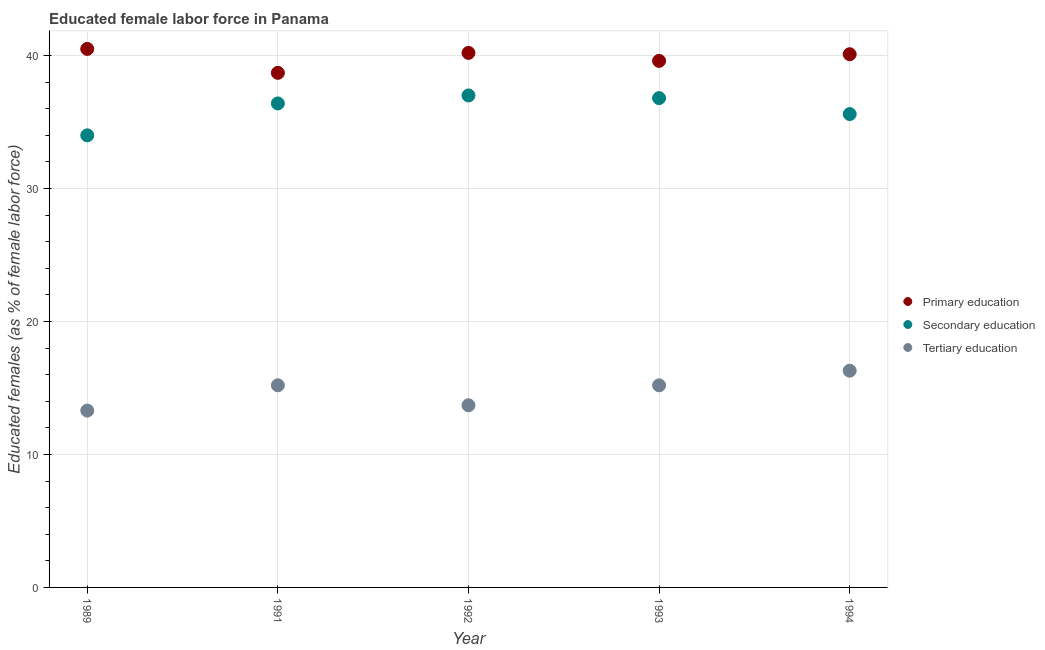How many different coloured dotlines are there?
Ensure brevity in your answer.  3. Is the number of dotlines equal to the number of legend labels?
Offer a very short reply. Yes. What is the percentage of female labor force who received primary education in 1991?
Keep it short and to the point. 38.7. Across all years, what is the maximum percentage of female labor force who received tertiary education?
Your answer should be compact. 16.3. Across all years, what is the minimum percentage of female labor force who received tertiary education?
Keep it short and to the point. 13.3. In which year was the percentage of female labor force who received secondary education maximum?
Provide a succinct answer. 1992. In which year was the percentage of female labor force who received secondary education minimum?
Give a very brief answer. 1989. What is the total percentage of female labor force who received secondary education in the graph?
Keep it short and to the point. 179.8. What is the difference between the percentage of female labor force who received secondary education in 1989 and that in 1991?
Ensure brevity in your answer.  -2.4. What is the difference between the percentage of female labor force who received primary education in 1991 and the percentage of female labor force who received secondary education in 1992?
Give a very brief answer. 1.7. What is the average percentage of female labor force who received secondary education per year?
Your response must be concise. 35.96. In the year 1993, what is the difference between the percentage of female labor force who received tertiary education and percentage of female labor force who received secondary education?
Provide a succinct answer. -21.6. In how many years, is the percentage of female labor force who received primary education greater than 10 %?
Ensure brevity in your answer.  5. What is the ratio of the percentage of female labor force who received secondary education in 1991 to that in 1993?
Provide a succinct answer. 0.99. Is the percentage of female labor force who received secondary education in 1991 less than that in 1993?
Offer a terse response. Yes. Is the difference between the percentage of female labor force who received tertiary education in 1991 and 1994 greater than the difference between the percentage of female labor force who received secondary education in 1991 and 1994?
Ensure brevity in your answer.  No. What is the difference between the highest and the second highest percentage of female labor force who received tertiary education?
Keep it short and to the point. 1.1. What is the difference between the highest and the lowest percentage of female labor force who received primary education?
Offer a terse response. 1.8. In how many years, is the percentage of female labor force who received secondary education greater than the average percentage of female labor force who received secondary education taken over all years?
Make the answer very short. 3. Is it the case that in every year, the sum of the percentage of female labor force who received primary education and percentage of female labor force who received secondary education is greater than the percentage of female labor force who received tertiary education?
Your answer should be compact. Yes. Is the percentage of female labor force who received primary education strictly greater than the percentage of female labor force who received tertiary education over the years?
Your answer should be compact. Yes. Is the percentage of female labor force who received tertiary education strictly less than the percentage of female labor force who received primary education over the years?
Your answer should be compact. Yes. How many dotlines are there?
Your answer should be very brief. 3. How many years are there in the graph?
Your answer should be compact. 5. Are the values on the major ticks of Y-axis written in scientific E-notation?
Your answer should be compact. No. What is the title of the graph?
Your response must be concise. Educated female labor force in Panama. What is the label or title of the X-axis?
Give a very brief answer. Year. What is the label or title of the Y-axis?
Provide a succinct answer. Educated females (as % of female labor force). What is the Educated females (as % of female labor force) of Primary education in 1989?
Your answer should be very brief. 40.5. What is the Educated females (as % of female labor force) in Secondary education in 1989?
Provide a short and direct response. 34. What is the Educated females (as % of female labor force) of Tertiary education in 1989?
Provide a succinct answer. 13.3. What is the Educated females (as % of female labor force) in Primary education in 1991?
Your answer should be compact. 38.7. What is the Educated females (as % of female labor force) in Secondary education in 1991?
Make the answer very short. 36.4. What is the Educated females (as % of female labor force) of Tertiary education in 1991?
Offer a terse response. 15.2. What is the Educated females (as % of female labor force) of Primary education in 1992?
Provide a short and direct response. 40.2. What is the Educated females (as % of female labor force) in Tertiary education in 1992?
Your answer should be very brief. 13.7. What is the Educated females (as % of female labor force) of Primary education in 1993?
Your response must be concise. 39.6. What is the Educated females (as % of female labor force) of Secondary education in 1993?
Provide a succinct answer. 36.8. What is the Educated females (as % of female labor force) in Tertiary education in 1993?
Make the answer very short. 15.2. What is the Educated females (as % of female labor force) of Primary education in 1994?
Offer a terse response. 40.1. What is the Educated females (as % of female labor force) of Secondary education in 1994?
Provide a short and direct response. 35.6. What is the Educated females (as % of female labor force) in Tertiary education in 1994?
Your answer should be very brief. 16.3. Across all years, what is the maximum Educated females (as % of female labor force) of Primary education?
Your response must be concise. 40.5. Across all years, what is the maximum Educated females (as % of female labor force) in Tertiary education?
Provide a short and direct response. 16.3. Across all years, what is the minimum Educated females (as % of female labor force) of Primary education?
Provide a succinct answer. 38.7. Across all years, what is the minimum Educated females (as % of female labor force) of Tertiary education?
Provide a succinct answer. 13.3. What is the total Educated females (as % of female labor force) in Primary education in the graph?
Give a very brief answer. 199.1. What is the total Educated females (as % of female labor force) in Secondary education in the graph?
Your answer should be very brief. 179.8. What is the total Educated females (as % of female labor force) of Tertiary education in the graph?
Offer a very short reply. 73.7. What is the difference between the Educated females (as % of female labor force) in Secondary education in 1989 and that in 1991?
Provide a short and direct response. -2.4. What is the difference between the Educated females (as % of female labor force) of Secondary education in 1989 and that in 1993?
Ensure brevity in your answer.  -2.8. What is the difference between the Educated females (as % of female labor force) of Tertiary education in 1989 and that in 1993?
Keep it short and to the point. -1.9. What is the difference between the Educated females (as % of female labor force) in Primary education in 1989 and that in 1994?
Offer a very short reply. 0.4. What is the difference between the Educated females (as % of female labor force) of Secondary education in 1989 and that in 1994?
Your answer should be compact. -1.6. What is the difference between the Educated females (as % of female labor force) of Tertiary education in 1989 and that in 1994?
Your response must be concise. -3. What is the difference between the Educated females (as % of female labor force) of Primary education in 1991 and that in 1992?
Provide a short and direct response. -1.5. What is the difference between the Educated females (as % of female labor force) of Secondary education in 1991 and that in 1992?
Provide a succinct answer. -0.6. What is the difference between the Educated females (as % of female labor force) in Primary education in 1991 and that in 1993?
Give a very brief answer. -0.9. What is the difference between the Educated females (as % of female labor force) in Secondary education in 1991 and that in 1993?
Make the answer very short. -0.4. What is the difference between the Educated females (as % of female labor force) of Tertiary education in 1991 and that in 1993?
Your answer should be compact. 0. What is the difference between the Educated females (as % of female labor force) of Primary education in 1991 and that in 1994?
Your answer should be compact. -1.4. What is the difference between the Educated females (as % of female labor force) in Tertiary education in 1991 and that in 1994?
Provide a short and direct response. -1.1. What is the difference between the Educated females (as % of female labor force) in Primary education in 1992 and that in 1993?
Give a very brief answer. 0.6. What is the difference between the Educated females (as % of female labor force) of Secondary education in 1992 and that in 1993?
Keep it short and to the point. 0.2. What is the difference between the Educated females (as % of female labor force) in Tertiary education in 1992 and that in 1993?
Offer a very short reply. -1.5. What is the difference between the Educated females (as % of female labor force) of Primary education in 1992 and that in 1994?
Give a very brief answer. 0.1. What is the difference between the Educated females (as % of female labor force) of Secondary education in 1992 and that in 1994?
Provide a short and direct response. 1.4. What is the difference between the Educated females (as % of female labor force) in Tertiary education in 1992 and that in 1994?
Provide a succinct answer. -2.6. What is the difference between the Educated females (as % of female labor force) of Primary education in 1993 and that in 1994?
Ensure brevity in your answer.  -0.5. What is the difference between the Educated females (as % of female labor force) in Primary education in 1989 and the Educated females (as % of female labor force) in Tertiary education in 1991?
Make the answer very short. 25.3. What is the difference between the Educated females (as % of female labor force) of Primary education in 1989 and the Educated females (as % of female labor force) of Secondary education in 1992?
Provide a succinct answer. 3.5. What is the difference between the Educated females (as % of female labor force) of Primary education in 1989 and the Educated females (as % of female labor force) of Tertiary education in 1992?
Provide a succinct answer. 26.8. What is the difference between the Educated females (as % of female labor force) in Secondary education in 1989 and the Educated females (as % of female labor force) in Tertiary education in 1992?
Your response must be concise. 20.3. What is the difference between the Educated females (as % of female labor force) in Primary education in 1989 and the Educated females (as % of female labor force) in Tertiary education in 1993?
Ensure brevity in your answer.  25.3. What is the difference between the Educated females (as % of female labor force) in Secondary education in 1989 and the Educated females (as % of female labor force) in Tertiary education in 1993?
Provide a short and direct response. 18.8. What is the difference between the Educated females (as % of female labor force) in Primary education in 1989 and the Educated females (as % of female labor force) in Tertiary education in 1994?
Ensure brevity in your answer.  24.2. What is the difference between the Educated females (as % of female labor force) of Secondary education in 1989 and the Educated females (as % of female labor force) of Tertiary education in 1994?
Keep it short and to the point. 17.7. What is the difference between the Educated females (as % of female labor force) of Primary education in 1991 and the Educated females (as % of female labor force) of Secondary education in 1992?
Provide a short and direct response. 1.7. What is the difference between the Educated females (as % of female labor force) in Primary education in 1991 and the Educated females (as % of female labor force) in Tertiary education in 1992?
Give a very brief answer. 25. What is the difference between the Educated females (as % of female labor force) of Secondary education in 1991 and the Educated females (as % of female labor force) of Tertiary education in 1992?
Provide a succinct answer. 22.7. What is the difference between the Educated females (as % of female labor force) of Primary education in 1991 and the Educated females (as % of female labor force) of Secondary education in 1993?
Provide a succinct answer. 1.9. What is the difference between the Educated females (as % of female labor force) in Secondary education in 1991 and the Educated females (as % of female labor force) in Tertiary education in 1993?
Provide a succinct answer. 21.2. What is the difference between the Educated females (as % of female labor force) of Primary education in 1991 and the Educated females (as % of female labor force) of Secondary education in 1994?
Give a very brief answer. 3.1. What is the difference between the Educated females (as % of female labor force) of Primary education in 1991 and the Educated females (as % of female labor force) of Tertiary education in 1994?
Offer a very short reply. 22.4. What is the difference between the Educated females (as % of female labor force) in Secondary education in 1991 and the Educated females (as % of female labor force) in Tertiary education in 1994?
Your answer should be very brief. 20.1. What is the difference between the Educated females (as % of female labor force) of Primary education in 1992 and the Educated females (as % of female labor force) of Secondary education in 1993?
Your response must be concise. 3.4. What is the difference between the Educated females (as % of female labor force) of Primary education in 1992 and the Educated females (as % of female labor force) of Tertiary education in 1993?
Provide a short and direct response. 25. What is the difference between the Educated females (as % of female labor force) in Secondary education in 1992 and the Educated females (as % of female labor force) in Tertiary education in 1993?
Offer a terse response. 21.8. What is the difference between the Educated females (as % of female labor force) in Primary education in 1992 and the Educated females (as % of female labor force) in Secondary education in 1994?
Your answer should be compact. 4.6. What is the difference between the Educated females (as % of female labor force) of Primary education in 1992 and the Educated females (as % of female labor force) of Tertiary education in 1994?
Offer a very short reply. 23.9. What is the difference between the Educated females (as % of female labor force) in Secondary education in 1992 and the Educated females (as % of female labor force) in Tertiary education in 1994?
Your answer should be compact. 20.7. What is the difference between the Educated females (as % of female labor force) of Primary education in 1993 and the Educated females (as % of female labor force) of Tertiary education in 1994?
Provide a succinct answer. 23.3. What is the average Educated females (as % of female labor force) of Primary education per year?
Offer a terse response. 39.82. What is the average Educated females (as % of female labor force) in Secondary education per year?
Ensure brevity in your answer.  35.96. What is the average Educated females (as % of female labor force) in Tertiary education per year?
Keep it short and to the point. 14.74. In the year 1989, what is the difference between the Educated females (as % of female labor force) in Primary education and Educated females (as % of female labor force) in Tertiary education?
Offer a very short reply. 27.2. In the year 1989, what is the difference between the Educated females (as % of female labor force) in Secondary education and Educated females (as % of female labor force) in Tertiary education?
Provide a succinct answer. 20.7. In the year 1991, what is the difference between the Educated females (as % of female labor force) in Primary education and Educated females (as % of female labor force) in Tertiary education?
Your response must be concise. 23.5. In the year 1991, what is the difference between the Educated females (as % of female labor force) in Secondary education and Educated females (as % of female labor force) in Tertiary education?
Offer a very short reply. 21.2. In the year 1992, what is the difference between the Educated females (as % of female labor force) of Primary education and Educated females (as % of female labor force) of Tertiary education?
Offer a very short reply. 26.5. In the year 1992, what is the difference between the Educated females (as % of female labor force) in Secondary education and Educated females (as % of female labor force) in Tertiary education?
Your answer should be very brief. 23.3. In the year 1993, what is the difference between the Educated females (as % of female labor force) in Primary education and Educated females (as % of female labor force) in Tertiary education?
Keep it short and to the point. 24.4. In the year 1993, what is the difference between the Educated females (as % of female labor force) of Secondary education and Educated females (as % of female labor force) of Tertiary education?
Offer a very short reply. 21.6. In the year 1994, what is the difference between the Educated females (as % of female labor force) in Primary education and Educated females (as % of female labor force) in Secondary education?
Offer a very short reply. 4.5. In the year 1994, what is the difference between the Educated females (as % of female labor force) of Primary education and Educated females (as % of female labor force) of Tertiary education?
Keep it short and to the point. 23.8. In the year 1994, what is the difference between the Educated females (as % of female labor force) in Secondary education and Educated females (as % of female labor force) in Tertiary education?
Keep it short and to the point. 19.3. What is the ratio of the Educated females (as % of female labor force) of Primary education in 1989 to that in 1991?
Keep it short and to the point. 1.05. What is the ratio of the Educated females (as % of female labor force) of Secondary education in 1989 to that in 1991?
Your response must be concise. 0.93. What is the ratio of the Educated females (as % of female labor force) in Primary education in 1989 to that in 1992?
Offer a terse response. 1.01. What is the ratio of the Educated females (as % of female labor force) of Secondary education in 1989 to that in 1992?
Offer a very short reply. 0.92. What is the ratio of the Educated females (as % of female labor force) in Tertiary education in 1989 to that in 1992?
Your answer should be very brief. 0.97. What is the ratio of the Educated females (as % of female labor force) of Primary education in 1989 to that in 1993?
Give a very brief answer. 1.02. What is the ratio of the Educated females (as % of female labor force) in Secondary education in 1989 to that in 1993?
Provide a short and direct response. 0.92. What is the ratio of the Educated females (as % of female labor force) in Tertiary education in 1989 to that in 1993?
Keep it short and to the point. 0.88. What is the ratio of the Educated females (as % of female labor force) of Secondary education in 1989 to that in 1994?
Provide a succinct answer. 0.96. What is the ratio of the Educated females (as % of female labor force) in Tertiary education in 1989 to that in 1994?
Ensure brevity in your answer.  0.82. What is the ratio of the Educated females (as % of female labor force) of Primary education in 1991 to that in 1992?
Your response must be concise. 0.96. What is the ratio of the Educated females (as % of female labor force) in Secondary education in 1991 to that in 1992?
Offer a very short reply. 0.98. What is the ratio of the Educated females (as % of female labor force) of Tertiary education in 1991 to that in 1992?
Your response must be concise. 1.11. What is the ratio of the Educated females (as % of female labor force) of Primary education in 1991 to that in 1993?
Offer a terse response. 0.98. What is the ratio of the Educated females (as % of female labor force) in Tertiary education in 1991 to that in 1993?
Provide a succinct answer. 1. What is the ratio of the Educated females (as % of female labor force) in Primary education in 1991 to that in 1994?
Offer a very short reply. 0.97. What is the ratio of the Educated females (as % of female labor force) in Secondary education in 1991 to that in 1994?
Your answer should be compact. 1.02. What is the ratio of the Educated females (as % of female labor force) in Tertiary education in 1991 to that in 1994?
Your answer should be compact. 0.93. What is the ratio of the Educated females (as % of female labor force) of Primary education in 1992 to that in 1993?
Make the answer very short. 1.02. What is the ratio of the Educated females (as % of female labor force) in Secondary education in 1992 to that in 1993?
Make the answer very short. 1.01. What is the ratio of the Educated females (as % of female labor force) in Tertiary education in 1992 to that in 1993?
Ensure brevity in your answer.  0.9. What is the ratio of the Educated females (as % of female labor force) of Primary education in 1992 to that in 1994?
Give a very brief answer. 1. What is the ratio of the Educated females (as % of female labor force) of Secondary education in 1992 to that in 1994?
Your response must be concise. 1.04. What is the ratio of the Educated females (as % of female labor force) of Tertiary education in 1992 to that in 1994?
Offer a very short reply. 0.84. What is the ratio of the Educated females (as % of female labor force) of Primary education in 1993 to that in 1994?
Give a very brief answer. 0.99. What is the ratio of the Educated females (as % of female labor force) of Secondary education in 1993 to that in 1994?
Your answer should be very brief. 1.03. What is the ratio of the Educated females (as % of female labor force) in Tertiary education in 1993 to that in 1994?
Provide a succinct answer. 0.93. What is the difference between the highest and the second highest Educated females (as % of female labor force) of Secondary education?
Provide a short and direct response. 0.2. What is the difference between the highest and the lowest Educated females (as % of female labor force) in Primary education?
Keep it short and to the point. 1.8. What is the difference between the highest and the lowest Educated females (as % of female labor force) of Secondary education?
Your answer should be compact. 3. 